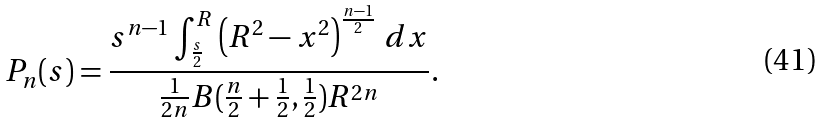<formula> <loc_0><loc_0><loc_500><loc_500>P _ { n } ( s ) = \frac { s ^ { n - 1 } \int _ { \frac { s } { 2 } } ^ { R } \left ( R ^ { 2 } - x ^ { 2 } \right ) ^ { \frac { n - 1 } { 2 } } \, d x } { \frac { 1 } { 2 n } B ( \frac { n } { 2 } + \frac { 1 } { 2 } , \frac { 1 } { 2 } ) R ^ { 2 n } } .</formula> 